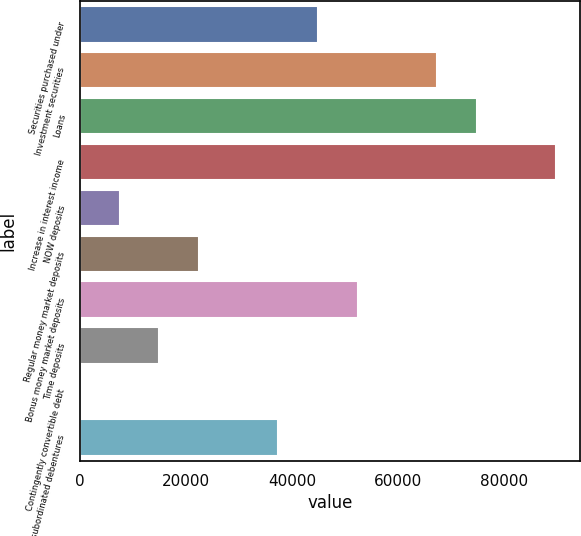<chart> <loc_0><loc_0><loc_500><loc_500><bar_chart><fcel>Securities purchased under<fcel>Investment securities<fcel>Loans<fcel>Increase in interest income<fcel>NOW deposits<fcel>Regular money market deposits<fcel>Bonus money market deposits<fcel>Time deposits<fcel>Contingently convertible debt<fcel>Junior subordinated debentures<nl><fcel>44933<fcel>67398.5<fcel>74887<fcel>89864<fcel>7490.5<fcel>22467.5<fcel>52421.5<fcel>14979<fcel>2<fcel>37444.5<nl></chart> 